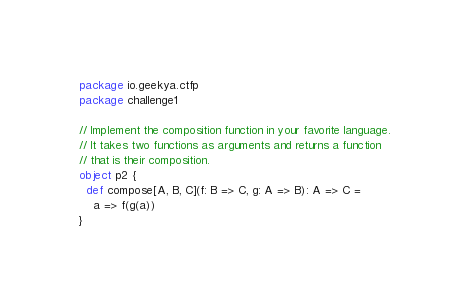<code> <loc_0><loc_0><loc_500><loc_500><_Scala_>package io.geekya.ctfp
package challenge1

// Implement the composition function in your favorite language.
// It takes two functions as arguments and returns a function
// that is their composition.
object p2 {
  def compose[A, B, C](f: B => C, g: A => B): A => C =
    a => f(g(a))
}</code> 